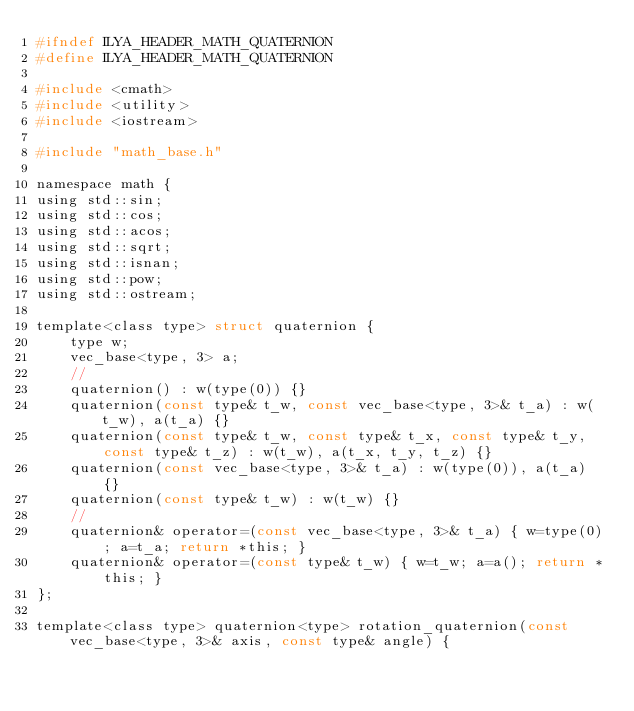Convert code to text. <code><loc_0><loc_0><loc_500><loc_500><_C_>#ifndef ILYA_HEADER_MATH_QUATERNION
#define ILYA_HEADER_MATH_QUATERNION

#include <cmath>
#include <utility>
#include <iostream>

#include "math_base.h"

namespace math {
using std::sin;
using std::cos;
using std::acos;
using std::sqrt;
using std::isnan;
using std::pow;
using std::ostream;

template<class type> struct quaternion {
    type w;
    vec_base<type, 3> a;
    //
    quaternion() : w(type(0)) {}
    quaternion(const type& t_w, const vec_base<type, 3>& t_a) : w(t_w), a(t_a) {}
    quaternion(const type& t_w, const type& t_x, const type& t_y, const type& t_z) : w(t_w), a(t_x, t_y, t_z) {}
    quaternion(const vec_base<type, 3>& t_a) : w(type(0)), a(t_a) {}
    quaternion(const type& t_w) : w(t_w) {}
    //
    quaternion& operator=(const vec_base<type, 3>& t_a) { w=type(0); a=t_a; return *this; }
    quaternion& operator=(const type& t_w) { w=t_w; a=a(); return *this; }
};

template<class type> quaternion<type> rotation_quaternion(const vec_base<type, 3>& axis, const type& angle) {</code> 